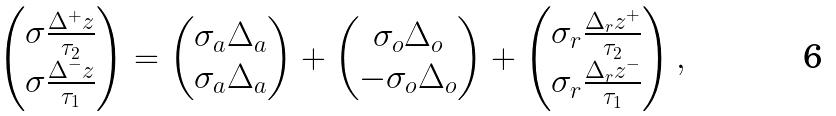<formula> <loc_0><loc_0><loc_500><loc_500>\begin{pmatrix} \sigma \frac { \Delta ^ { + } z } { \tau _ { 2 } } \\ \sigma \frac { \Delta ^ { - } z } { \tau _ { 1 } } \end{pmatrix} = \begin{pmatrix} \sigma _ { a } \Delta _ { a } \\ \sigma _ { a } \Delta _ { a } \end{pmatrix} + \begin{pmatrix} \sigma _ { o } \Delta _ { o } \\ - \sigma _ { o } \Delta _ { o } \end{pmatrix} + \begin{pmatrix} \sigma _ { r } \frac { \Delta _ { r } z ^ { + } } { \tau _ { 2 } } \\ \sigma _ { r } \frac { \Delta _ { r } z ^ { - } } { \tau _ { 1 } } \end{pmatrix} ,</formula> 